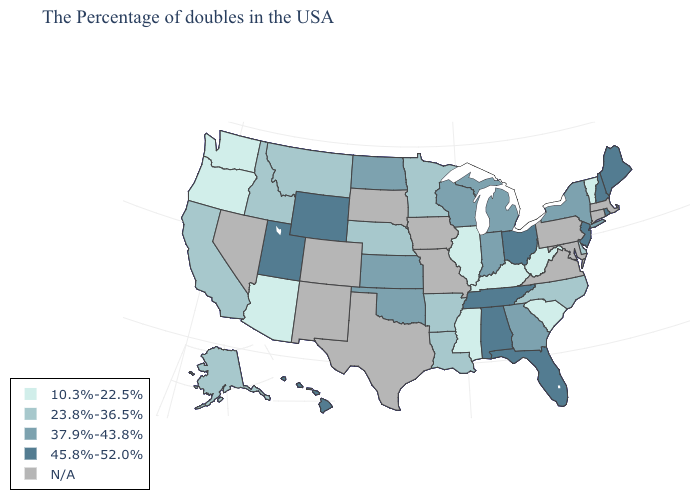Does Florida have the highest value in the South?
Write a very short answer. Yes. Name the states that have a value in the range 45.8%-52.0%?
Give a very brief answer. Maine, Rhode Island, New Hampshire, New Jersey, Ohio, Florida, Alabama, Tennessee, Wyoming, Utah, Hawaii. Does the map have missing data?
Concise answer only. Yes. Does the map have missing data?
Quick response, please. Yes. Which states have the lowest value in the USA?
Write a very short answer. Vermont, South Carolina, West Virginia, Kentucky, Illinois, Mississippi, Arizona, Washington, Oregon. Does Wisconsin have the highest value in the USA?
Be succinct. No. Which states hav the highest value in the West?
Short answer required. Wyoming, Utah, Hawaii. Does the first symbol in the legend represent the smallest category?
Give a very brief answer. Yes. Among the states that border Montana , does Wyoming have the highest value?
Write a very short answer. Yes. Name the states that have a value in the range 23.8%-36.5%?
Concise answer only. Delaware, North Carolina, Louisiana, Arkansas, Minnesota, Nebraska, Montana, Idaho, California, Alaska. Which states have the highest value in the USA?
Concise answer only. Maine, Rhode Island, New Hampshire, New Jersey, Ohio, Florida, Alabama, Tennessee, Wyoming, Utah, Hawaii. 